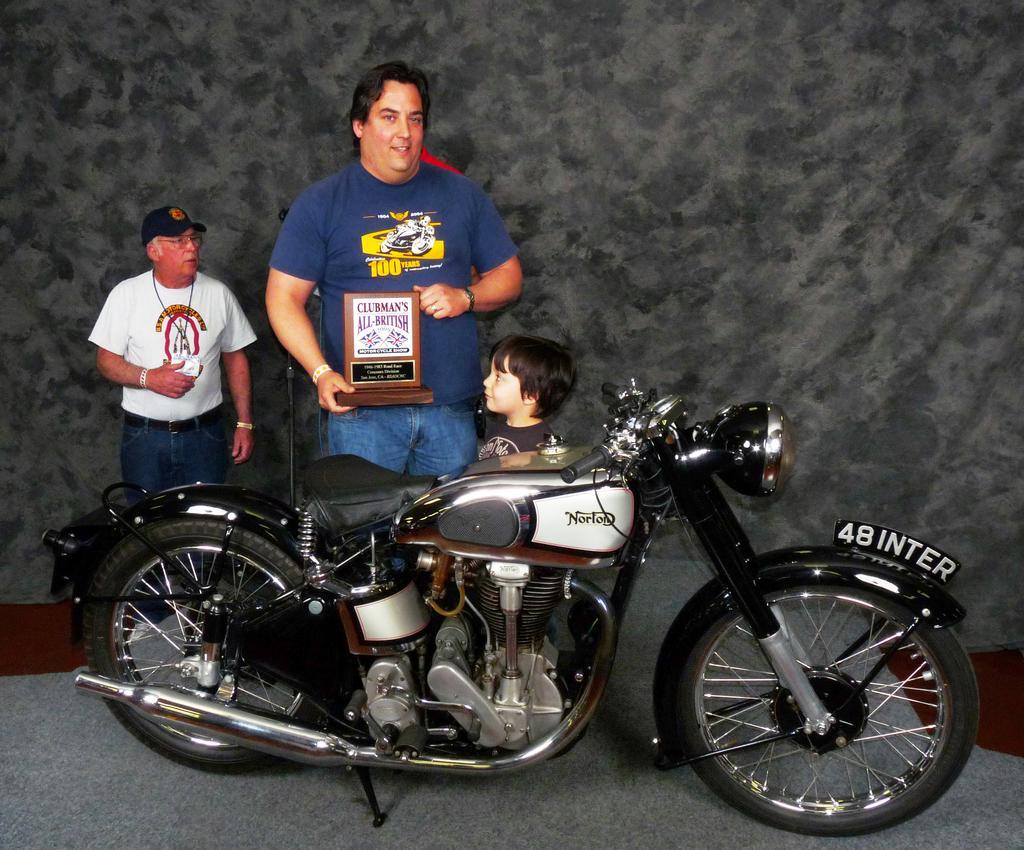Can you describe this image briefly? Three persons are in front of the bike. In the center we have a blue shirt color person Is holding a memento. 